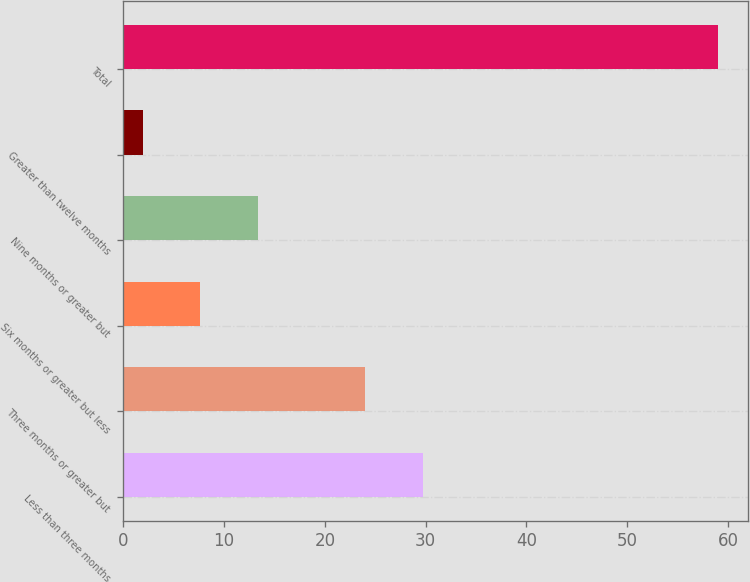<chart> <loc_0><loc_0><loc_500><loc_500><bar_chart><fcel>Less than three months<fcel>Three months or greater but<fcel>Six months or greater but less<fcel>Nine months or greater but<fcel>Greater than twelve months<fcel>Total<nl><fcel>29.71<fcel>24<fcel>7.65<fcel>13.36<fcel>1.94<fcel>59<nl></chart> 